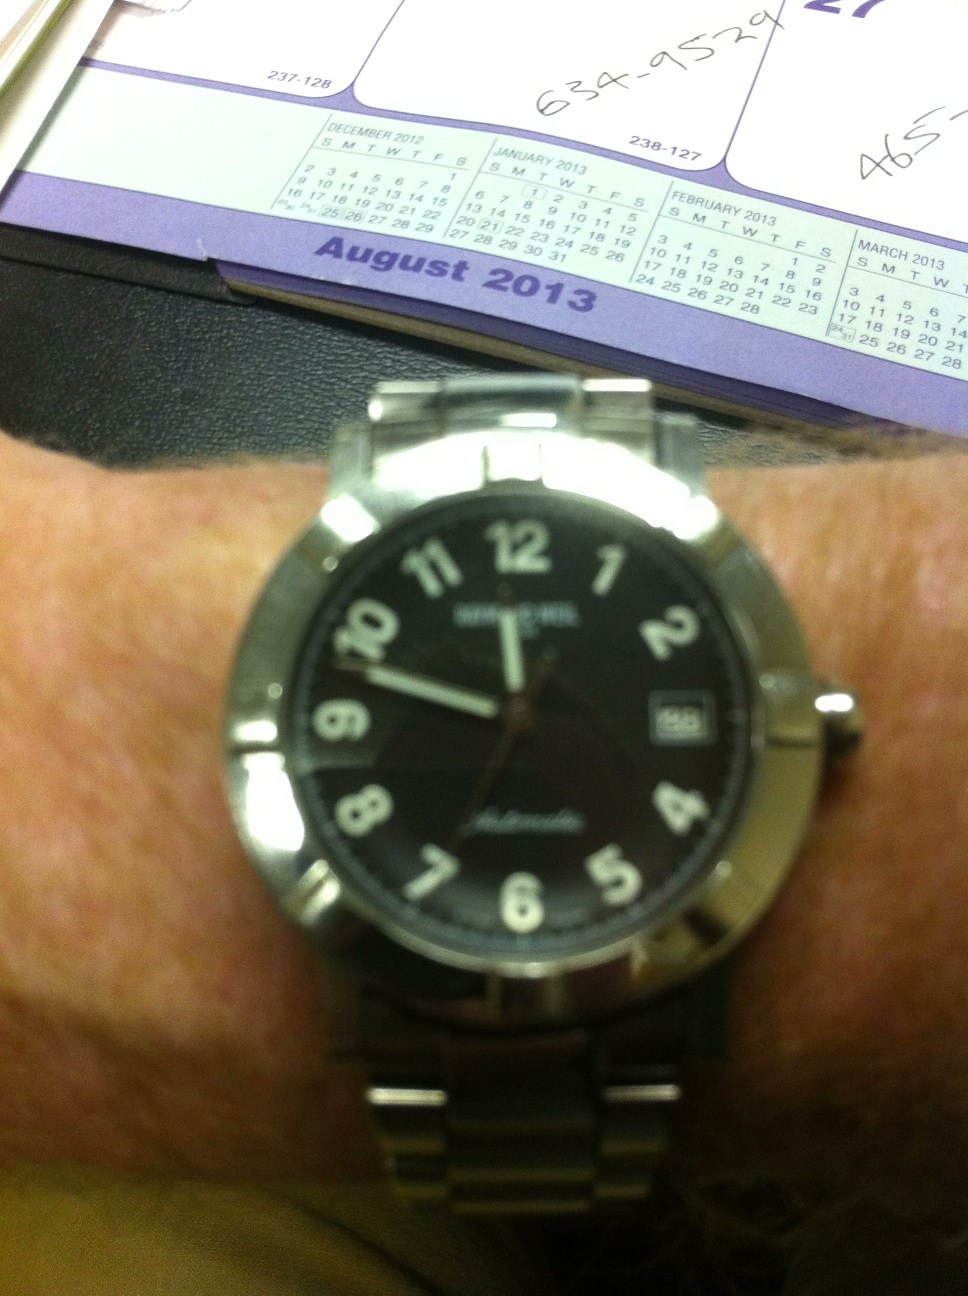What does the calendar date visible in the picture suggest? The visible calendar date shows 'August 2013', which provides context about the possible time frame when this image was captured. This can offer insights into the age of the watch and any historical or personal significance the watch might have to its owner during that period. 